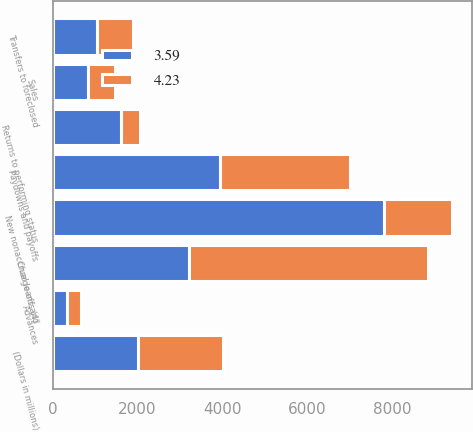<chart> <loc_0><loc_0><loc_500><loc_500><stacked_bar_chart><ecel><fcel>(Dollars in millions)<fcel>New nonaccrual loans and<fcel>Advances<fcel>Paydowns and payoffs<fcel>Sales<fcel>Returns to performing status<fcel>Charge-offs (4)<fcel>Transfers to foreclosed<nl><fcel>3.59<fcel>2010<fcel>7809<fcel>330<fcel>3938<fcel>841<fcel>1607<fcel>3221<fcel>1045<nl><fcel>4.23<fcel>2009<fcel>1607<fcel>339<fcel>3075<fcel>630<fcel>461<fcel>5626<fcel>857<nl></chart> 